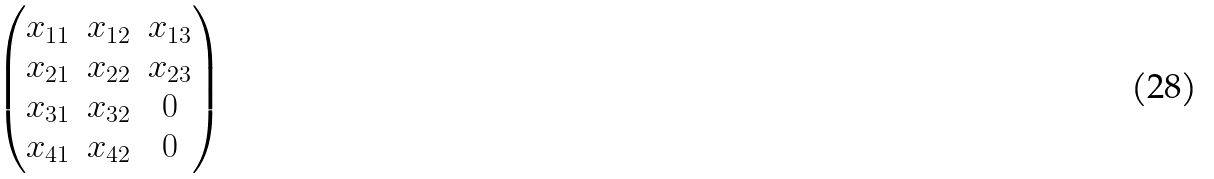<formula> <loc_0><loc_0><loc_500><loc_500>\begin{pmatrix} x _ { 1 1 } & x _ { 1 2 } & x _ { 1 3 } \\ x _ { 2 1 } & x _ { 2 2 } & x _ { 2 3 } \\ x _ { 3 1 } & x _ { 3 2 } & 0 \\ x _ { 4 1 } & x _ { 4 2 } & 0 \end{pmatrix}</formula> 